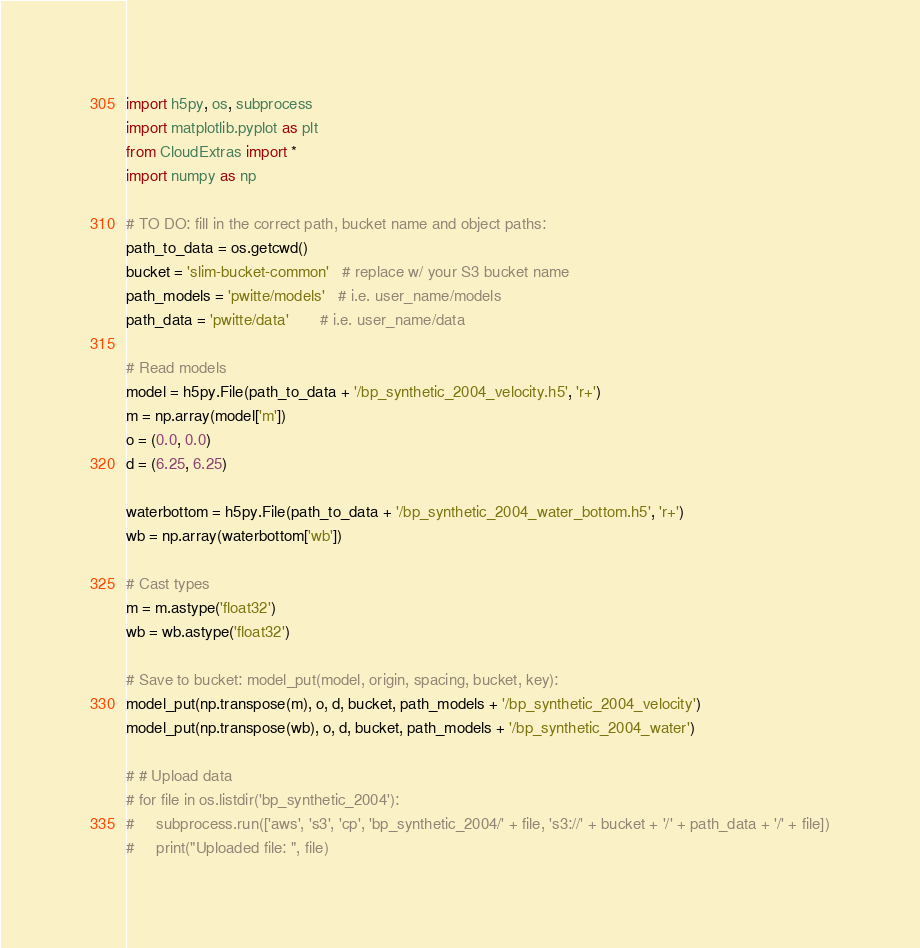<code> <loc_0><loc_0><loc_500><loc_500><_Python_>import h5py, os, subprocess
import matplotlib.pyplot as plt
from CloudExtras import *
import numpy as np

# TO DO: fill in the correct path, bucket name and object paths:
path_to_data = os.getcwd()
bucket = 'slim-bucket-common'   # replace w/ your S3 bucket name
path_models = 'pwitte/models'   # i.e. user_name/models
path_data = 'pwitte/data'       # i.e. user_name/data

# Read models
model = h5py.File(path_to_data + '/bp_synthetic_2004_velocity.h5', 'r+')
m = np.array(model['m'])
o = (0.0, 0.0)
d = (6.25, 6.25)

waterbottom = h5py.File(path_to_data + '/bp_synthetic_2004_water_bottom.h5', 'r+')
wb = np.array(waterbottom['wb'])

# Cast types
m = m.astype('float32')
wb = wb.astype('float32')

# Save to bucket: model_put(model, origin, spacing, bucket, key):
model_put(np.transpose(m), o, d, bucket, path_models + '/bp_synthetic_2004_velocity')
model_put(np.transpose(wb), o, d, bucket, path_models + '/bp_synthetic_2004_water')

# # Upload data
# for file in os.listdir('bp_synthetic_2004'):
#     subprocess.run(['aws', 's3', 'cp', 'bp_synthetic_2004/' + file, 's3://' + bucket + '/' + path_data + '/' + file])
#     print("Uploaded file: ", file)</code> 